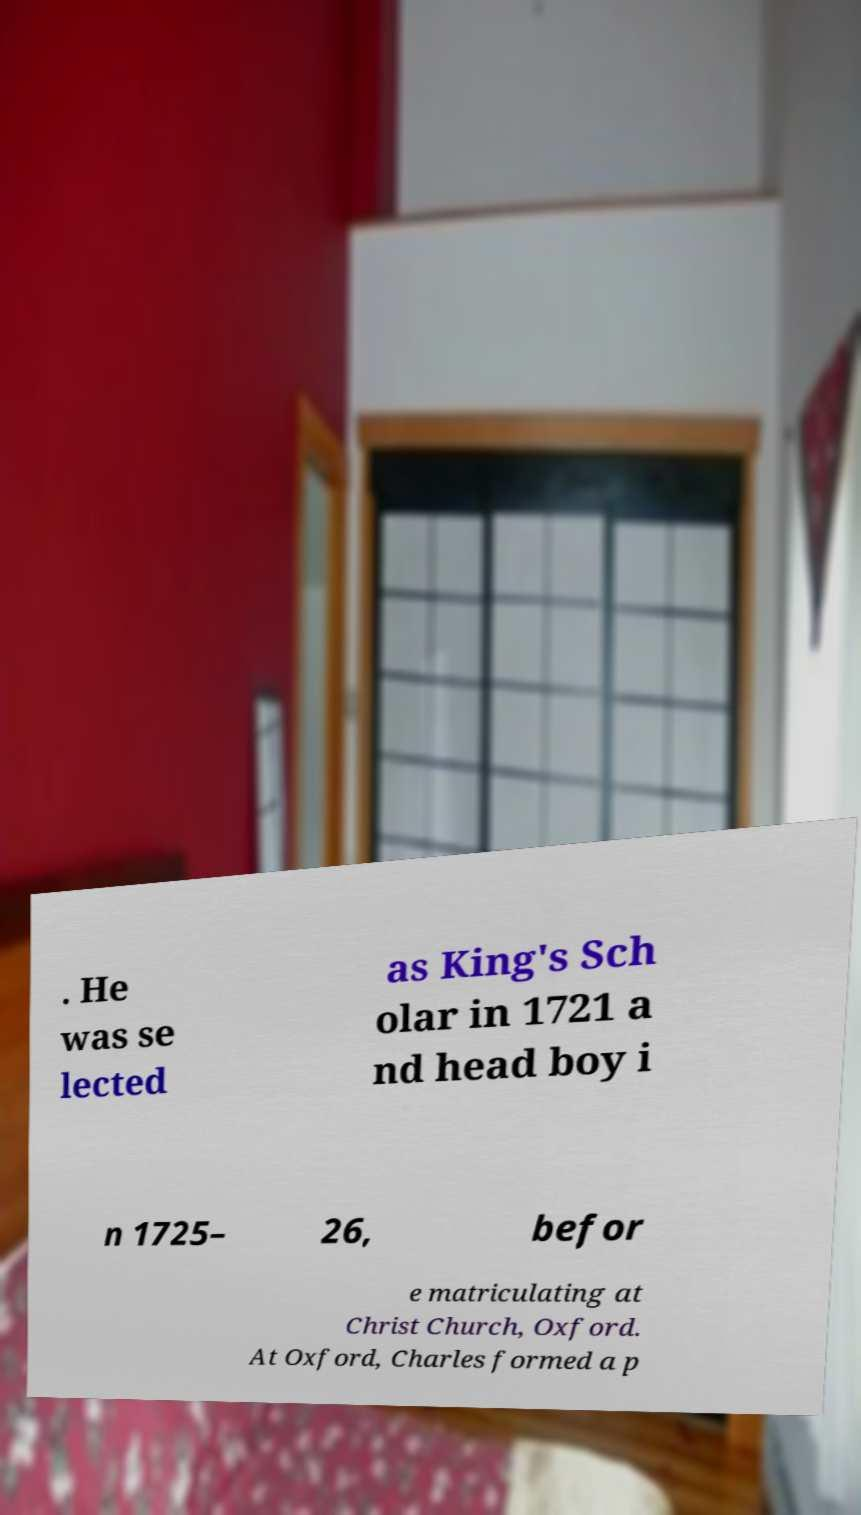Could you extract and type out the text from this image? . He was se lected as King's Sch olar in 1721 a nd head boy i n 1725– 26, befor e matriculating at Christ Church, Oxford. At Oxford, Charles formed a p 